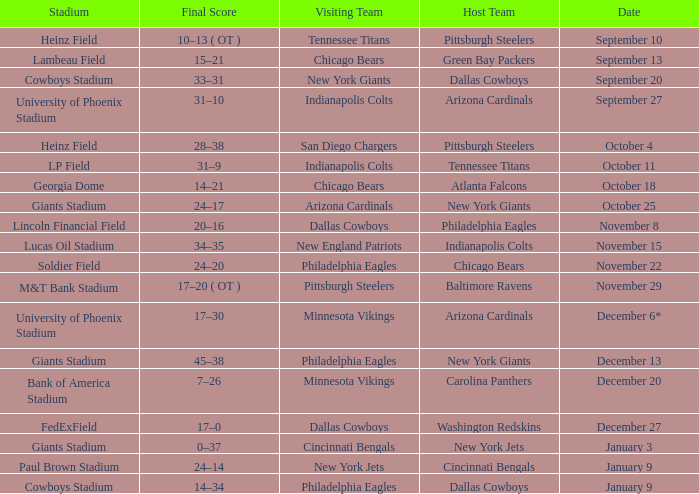I want to know the stadium for tennessee titans visiting Heinz Field. 